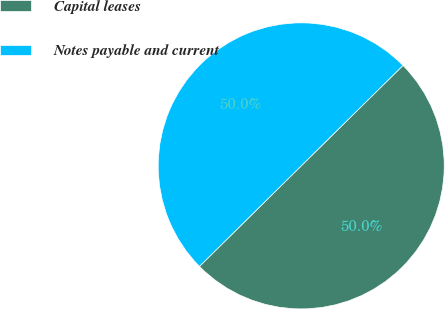Convert chart. <chart><loc_0><loc_0><loc_500><loc_500><pie_chart><fcel>Capital leases<fcel>Notes payable and current<nl><fcel>49.99%<fcel>50.01%<nl></chart> 